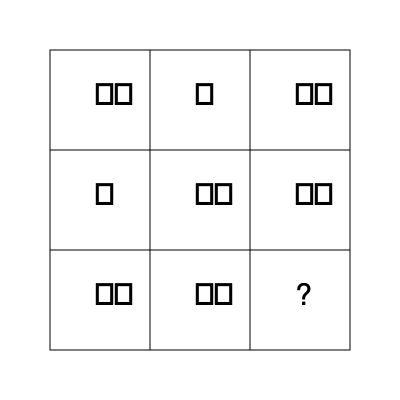In this 3x3 grid of assistive technology icons, each row and column contains exactly one of each icon type (eye-tracking 👁️, speech synthesis 💬, and gesture recognition 🖐️). What icon should replace the question mark to complete the pattern? To solve this pattern recognition problem, we need to analyze the grid row by row and column by column:

1. Row analysis:
   - Row 1: 👁️ 💬 🖐️
   - Row 2: 💬 🖐️ 👁️
   - Row 3: 🖐️ 👁️ ?

2. Column analysis:
   - Column 1: 👁️ 💬 🖐️
   - Column 2: 💬 🖐️ 👁️
   - Column 3: 🖐️ 👁️ ?

3. Pattern identification:
   - Each row and column must contain exactly one of each icon type.
   - The missing icon in Row 3 must be different from 🖐️ and 👁️.
   - The missing icon in Column 3 must be different from 🖐️ and 👁️.

4. Conclusion:
   The only icon that satisfies both row and column conditions is the speech synthesis icon 💬.

This pattern follows a Latin square arrangement, where each symbol appears exactly once in each row and column, which is common in spatial intelligence tests and relevant to organizing assistive technology interfaces.
Answer: 💬 (speech synthesis icon) 